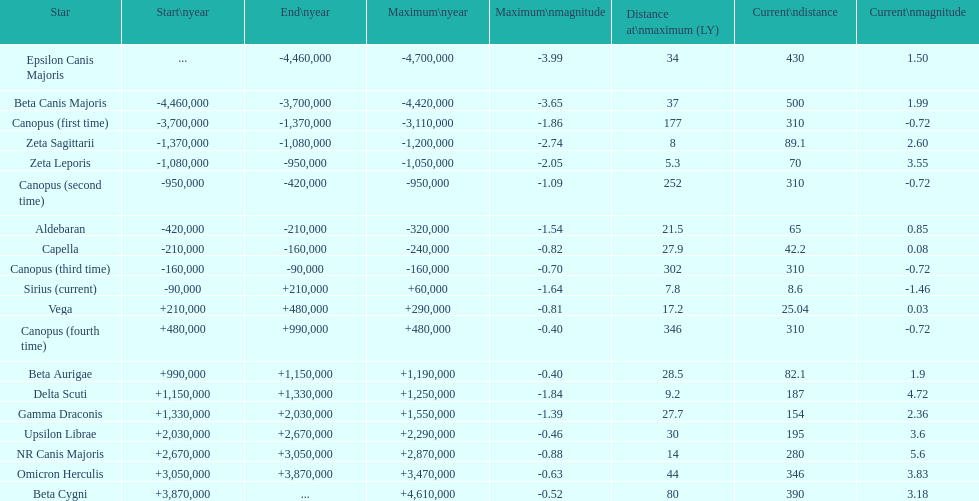What is the only star with a distance at maximum of 80? Beta Cygni. Would you mind parsing the complete table? {'header': ['Star', 'Start\\nyear', 'End\\nyear', 'Maximum\\nyear', 'Maximum\\nmagnitude', 'Distance at\\nmaximum (LY)', 'Current\\ndistance', 'Current\\nmagnitude'], 'rows': [['Epsilon Canis Majoris', '...', '-4,460,000', '-4,700,000', '-3.99', '34', '430', '1.50'], ['Beta Canis Majoris', '-4,460,000', '-3,700,000', '-4,420,000', '-3.65', '37', '500', '1.99'], ['Canopus (first time)', '-3,700,000', '-1,370,000', '-3,110,000', '-1.86', '177', '310', '-0.72'], ['Zeta Sagittarii', '-1,370,000', '-1,080,000', '-1,200,000', '-2.74', '8', '89.1', '2.60'], ['Zeta Leporis', '-1,080,000', '-950,000', '-1,050,000', '-2.05', '5.3', '70', '3.55'], ['Canopus (second time)', '-950,000', '-420,000', '-950,000', '-1.09', '252', '310', '-0.72'], ['Aldebaran', '-420,000', '-210,000', '-320,000', '-1.54', '21.5', '65', '0.85'], ['Capella', '-210,000', '-160,000', '-240,000', '-0.82', '27.9', '42.2', '0.08'], ['Canopus (third time)', '-160,000', '-90,000', '-160,000', '-0.70', '302', '310', '-0.72'], ['Sirius (current)', '-90,000', '+210,000', '+60,000', '-1.64', '7.8', '8.6', '-1.46'], ['Vega', '+210,000', '+480,000', '+290,000', '-0.81', '17.2', '25.04', '0.03'], ['Canopus (fourth time)', '+480,000', '+990,000', '+480,000', '-0.40', '346', '310', '-0.72'], ['Beta Aurigae', '+990,000', '+1,150,000', '+1,190,000', '-0.40', '28.5', '82.1', '1.9'], ['Delta Scuti', '+1,150,000', '+1,330,000', '+1,250,000', '-1.84', '9.2', '187', '4.72'], ['Gamma Draconis', '+1,330,000', '+2,030,000', '+1,550,000', '-1.39', '27.7', '154', '2.36'], ['Upsilon Librae', '+2,030,000', '+2,670,000', '+2,290,000', '-0.46', '30', '195', '3.6'], ['NR Canis Majoris', '+2,670,000', '+3,050,000', '+2,870,000', '-0.88', '14', '280', '5.6'], ['Omicron Herculis', '+3,050,000', '+3,870,000', '+3,470,000', '-0.63', '44', '346', '3.83'], ['Beta Cygni', '+3,870,000', '...', '+4,610,000', '-0.52', '80', '390', '3.18']]} 